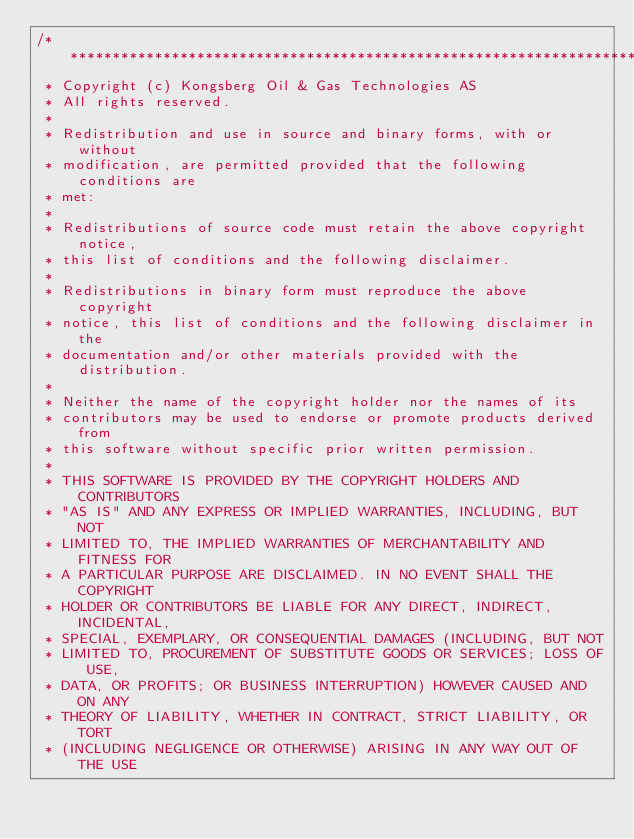Convert code to text. <code><loc_0><loc_0><loc_500><loc_500><_C++_>/**************************************************************************\
 * Copyright (c) Kongsberg Oil & Gas Technologies AS
 * All rights reserved.
 * 
 * Redistribution and use in source and binary forms, with or without
 * modification, are permitted provided that the following conditions are
 * met:
 * 
 * Redistributions of source code must retain the above copyright notice,
 * this list of conditions and the following disclaimer.
 * 
 * Redistributions in binary form must reproduce the above copyright
 * notice, this list of conditions and the following disclaimer in the
 * documentation and/or other materials provided with the distribution.
 * 
 * Neither the name of the copyright holder nor the names of its
 * contributors may be used to endorse or promote products derived from
 * this software without specific prior written permission.
 * 
 * THIS SOFTWARE IS PROVIDED BY THE COPYRIGHT HOLDERS AND CONTRIBUTORS
 * "AS IS" AND ANY EXPRESS OR IMPLIED WARRANTIES, INCLUDING, BUT NOT
 * LIMITED TO, THE IMPLIED WARRANTIES OF MERCHANTABILITY AND FITNESS FOR
 * A PARTICULAR PURPOSE ARE DISCLAIMED. IN NO EVENT SHALL THE COPYRIGHT
 * HOLDER OR CONTRIBUTORS BE LIABLE FOR ANY DIRECT, INDIRECT, INCIDENTAL,
 * SPECIAL, EXEMPLARY, OR CONSEQUENTIAL DAMAGES (INCLUDING, BUT NOT
 * LIMITED TO, PROCUREMENT OF SUBSTITUTE GOODS OR SERVICES; LOSS OF USE,
 * DATA, OR PROFITS; OR BUSINESS INTERRUPTION) HOWEVER CAUSED AND ON ANY
 * THEORY OF LIABILITY, WHETHER IN CONTRACT, STRICT LIABILITY, OR TORT
 * (INCLUDING NEGLIGENCE OR OTHERWISE) ARISING IN ANY WAY OUT OF THE USE</code> 